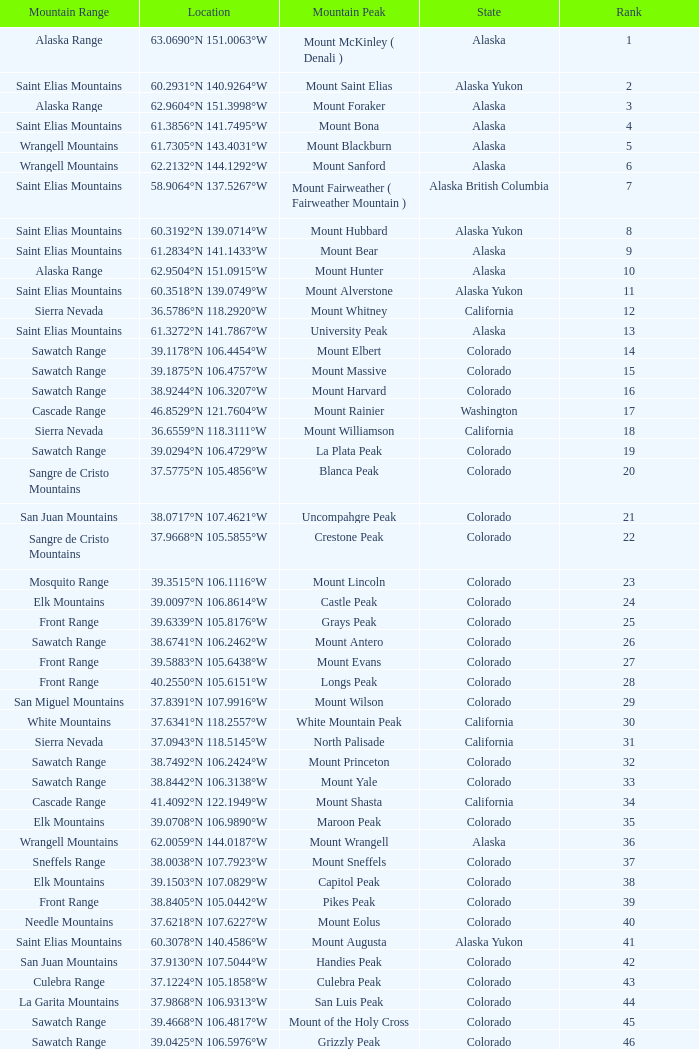What is the mountain peak when the location is 37.5775°n 105.4856°w? Blanca Peak. 